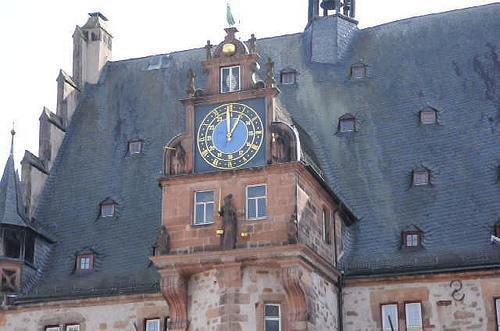How many lightning rods are visible?
Give a very brief answer. 1. How many dormers are on the roof?
Give a very brief answer. 9. 